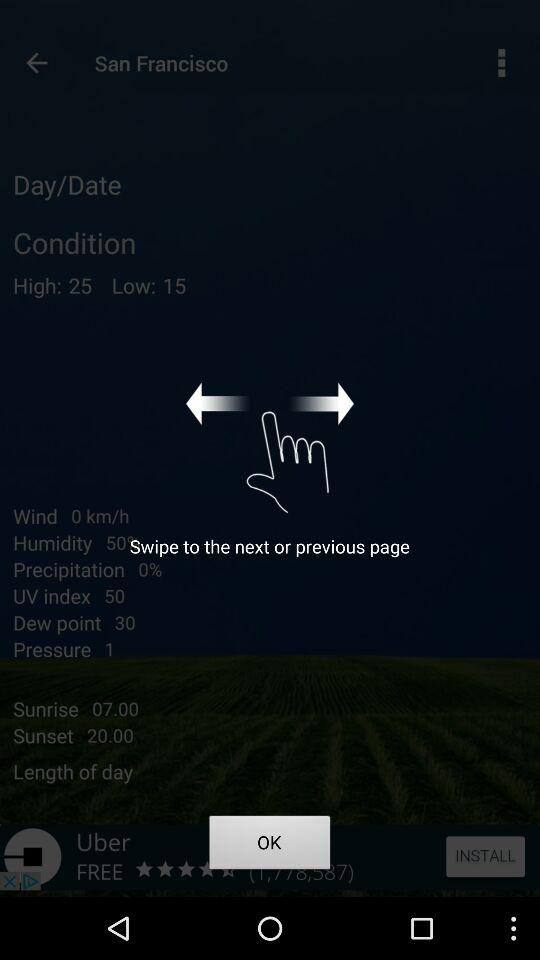When is the sunrise? The sunrise is at 7 a.m. 